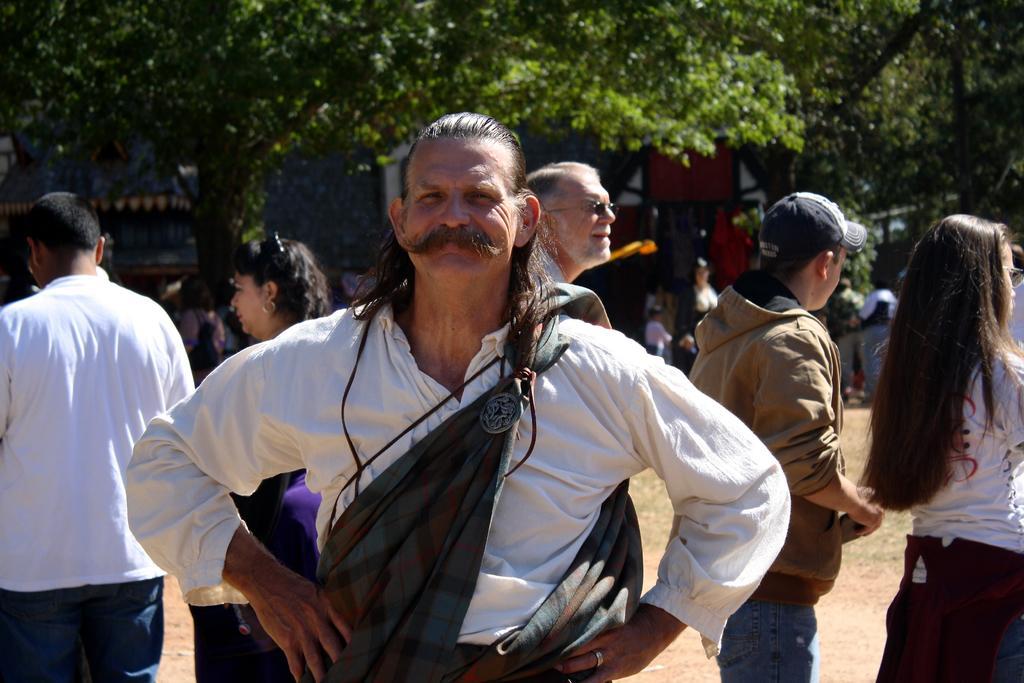In one or two sentences, can you explain what this image depicts? In this image in front there is a person. Behind him there are a few other people standing. In the background of the image there are buildings, trees. 